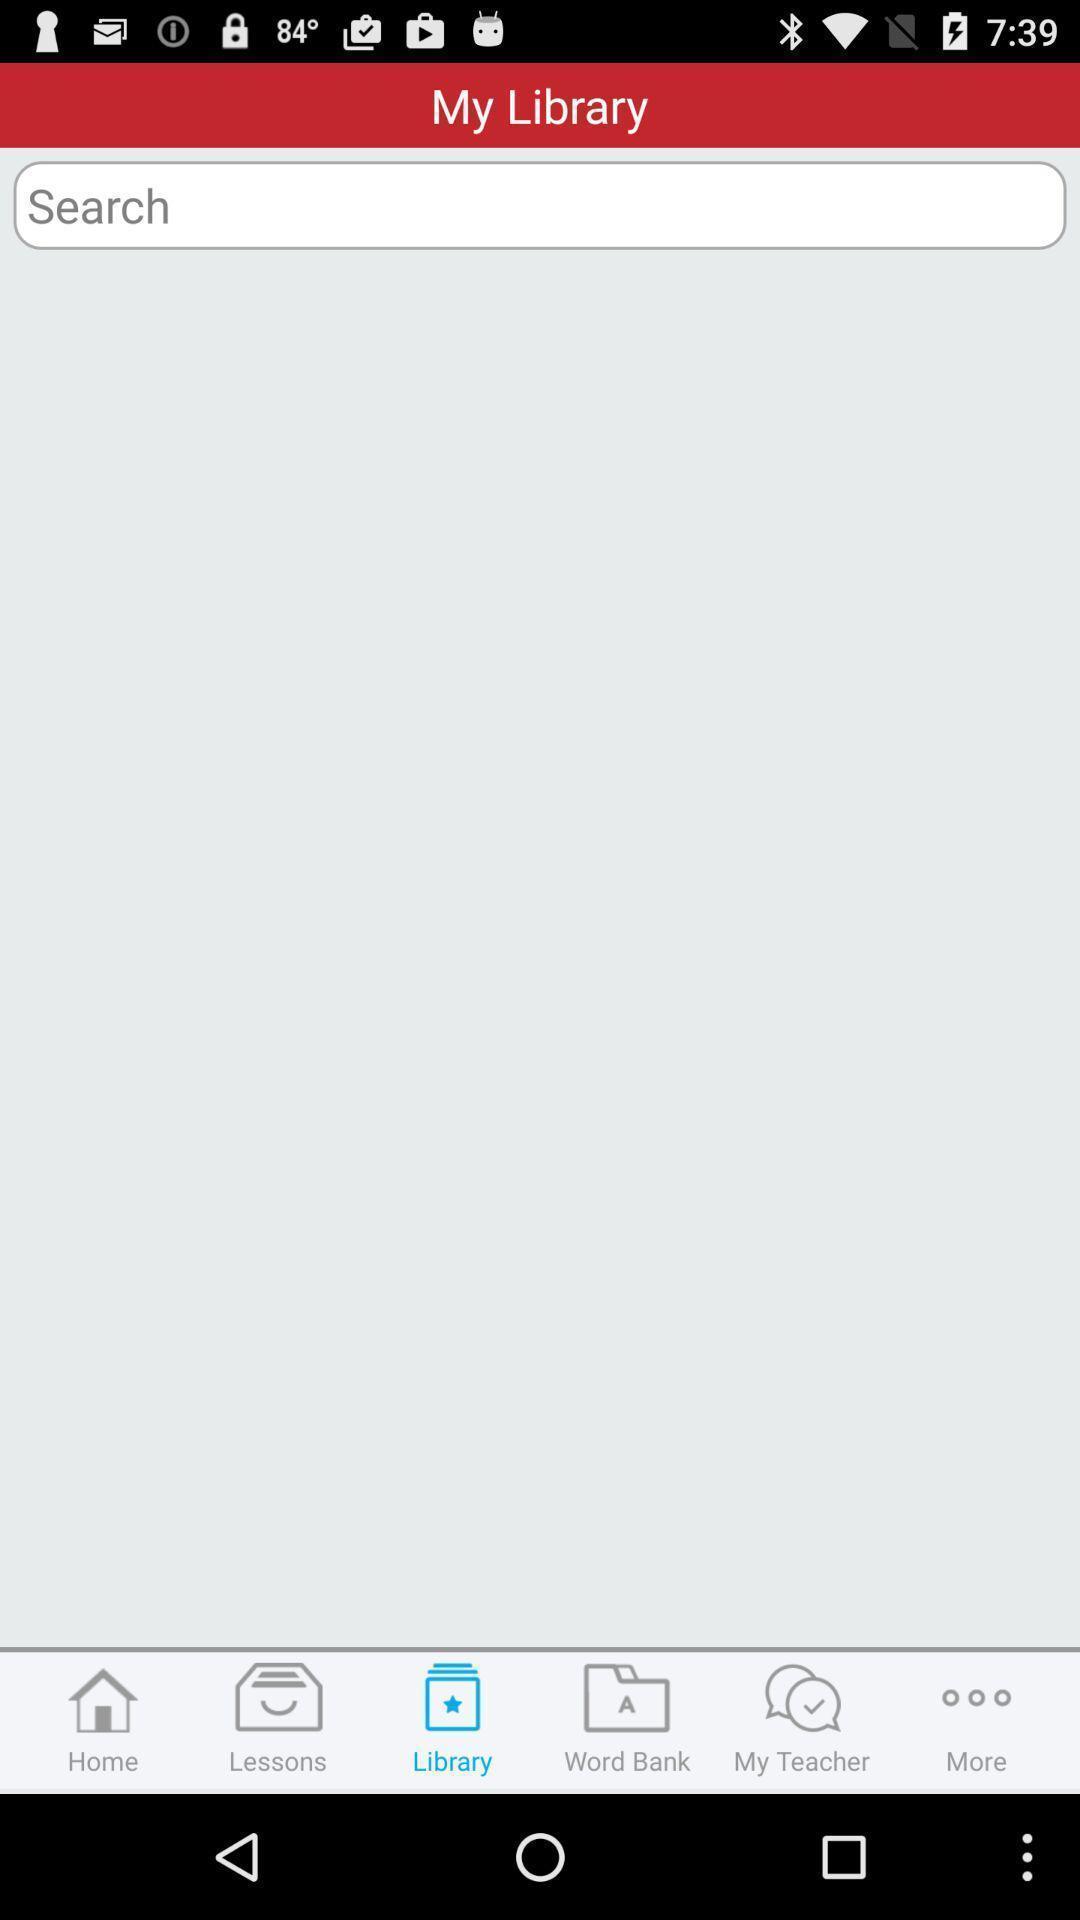Summarize the information in this screenshot. My library page of a language learning app. 